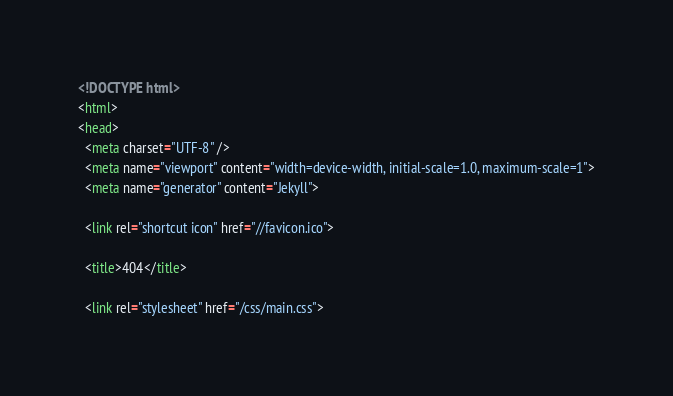Convert code to text. <code><loc_0><loc_0><loc_500><loc_500><_HTML_><!DOCTYPE html>
<html>
<head>
  <meta charset="UTF-8" />
  <meta name="viewport" content="width=device-width, initial-scale=1.0, maximum-scale=1">
  <meta name="generator" content="Jekyll">

  <link rel="shortcut icon" href="//favicon.ico">

  <title>404</title>

  <link rel="stylesheet" href="/css/main.css">
</code> 